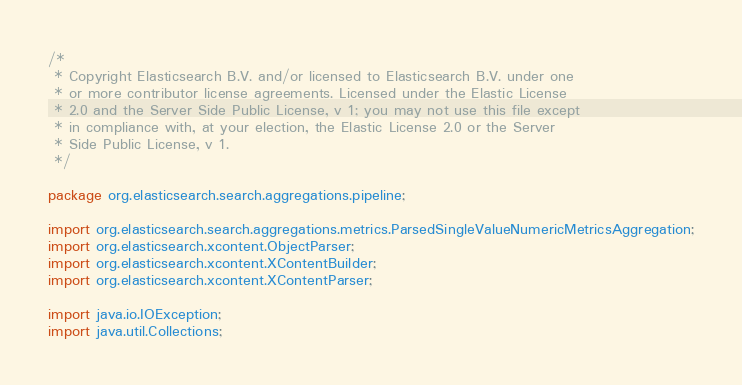<code> <loc_0><loc_0><loc_500><loc_500><_Java_>/*
 * Copyright Elasticsearch B.V. and/or licensed to Elasticsearch B.V. under one
 * or more contributor license agreements. Licensed under the Elastic License
 * 2.0 and the Server Side Public License, v 1; you may not use this file except
 * in compliance with, at your election, the Elastic License 2.0 or the Server
 * Side Public License, v 1.
 */

package org.elasticsearch.search.aggregations.pipeline;

import org.elasticsearch.search.aggregations.metrics.ParsedSingleValueNumericMetricsAggregation;
import org.elasticsearch.xcontent.ObjectParser;
import org.elasticsearch.xcontent.XContentBuilder;
import org.elasticsearch.xcontent.XContentParser;

import java.io.IOException;
import java.util.Collections;</code> 